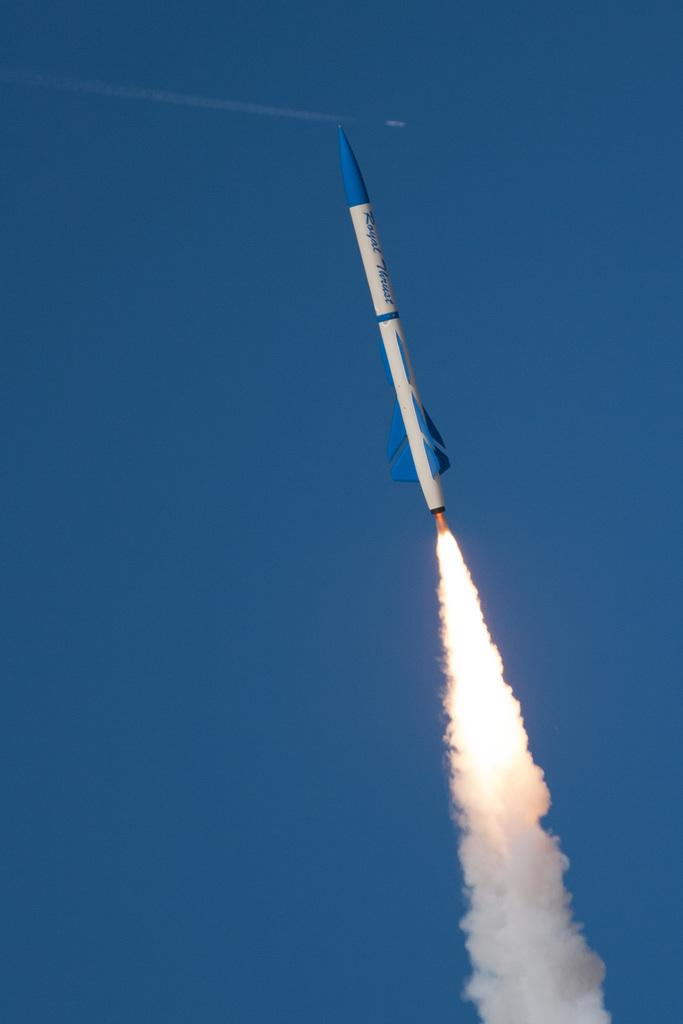What is the main subject of the image? The main subject of the image is a rocket. What is the rocket doing in the image? The rocket is going up in the image. What can be seen coming from the rocket? There is smoke coming from the rocket. What part of the sky is visible in the image? The sky is visible on the left side of the image. What type of comb is being used to groom the rocket in the image? There is no comb present in the image, nor is there any indication that the rocket is being groomed. 